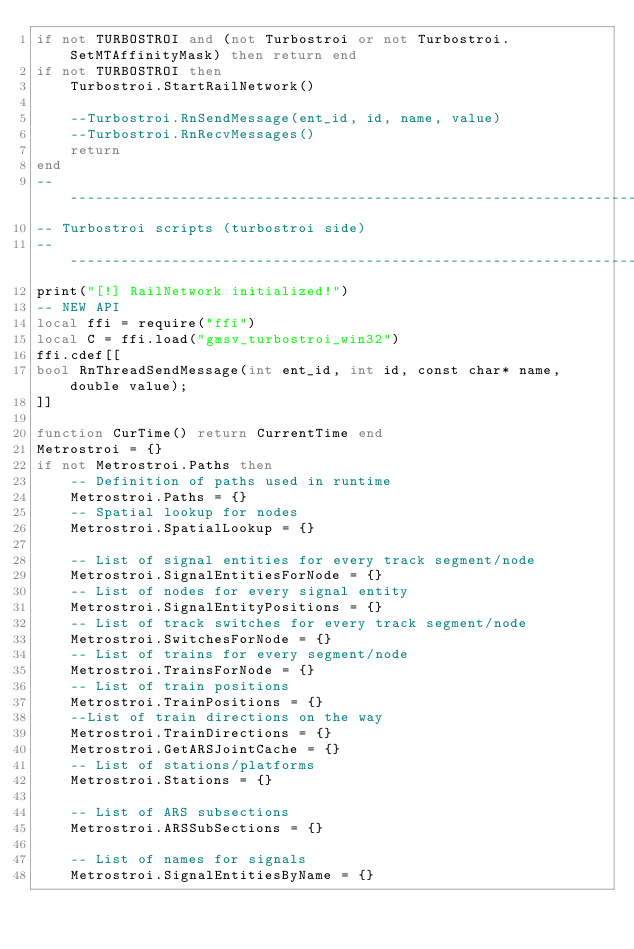Convert code to text. <code><loc_0><loc_0><loc_500><loc_500><_Lua_>if not TURBOSTROI and (not Turbostroi or not Turbostroi.SetMTAffinityMask) then return end
if not TURBOSTROI then
	Turbostroi.StartRailNetwork()

	--Turbostroi.RnSendMessage(ent_id, id, name, value)
	--Turbostroi.RnRecvMessages()
	return
end
--------------------------------------------------------------------------------
-- Turbostroi scripts (turbostroi side)
--------------------------------------------------------------------------------
print("[!] RailNetwork initialized!")
-- NEW API
local ffi = require("ffi")
local C = ffi.load("gmsv_turbostroi_win32")
ffi.cdef[[
bool RnThreadSendMessage(int ent_id, int id, const char* name, double value);
]]

function CurTime() return CurrentTime end
Metrostroi = {}
if not Metrostroi.Paths then
	-- Definition of paths used in runtime
	Metrostroi.Paths = {}
	-- Spatial lookup for nodes
	Metrostroi.SpatialLookup = {}

	-- List of signal entities for every track segment/node
	Metrostroi.SignalEntitiesForNode = {}
	-- List of nodes for every signal entity
	Metrostroi.SignalEntityPositions = {}
	-- List of track switches for every track segment/node
	Metrostroi.SwitchesForNode = {}
	-- List of trains for every segment/node
	Metrostroi.TrainsForNode = {}
	-- List of train positions
	Metrostroi.TrainPositions = {}
	--List of train directions on the way
	Metrostroi.TrainDirections = {}
	Metrostroi.GetARSJointCache = {}
	-- List of stations/platforms
	Metrostroi.Stations = {}

	-- List of ARS subsections
	Metrostroi.ARSSubSections = {}

	-- List of names for signals
	Metrostroi.SignalEntitiesByName = {}
</code> 